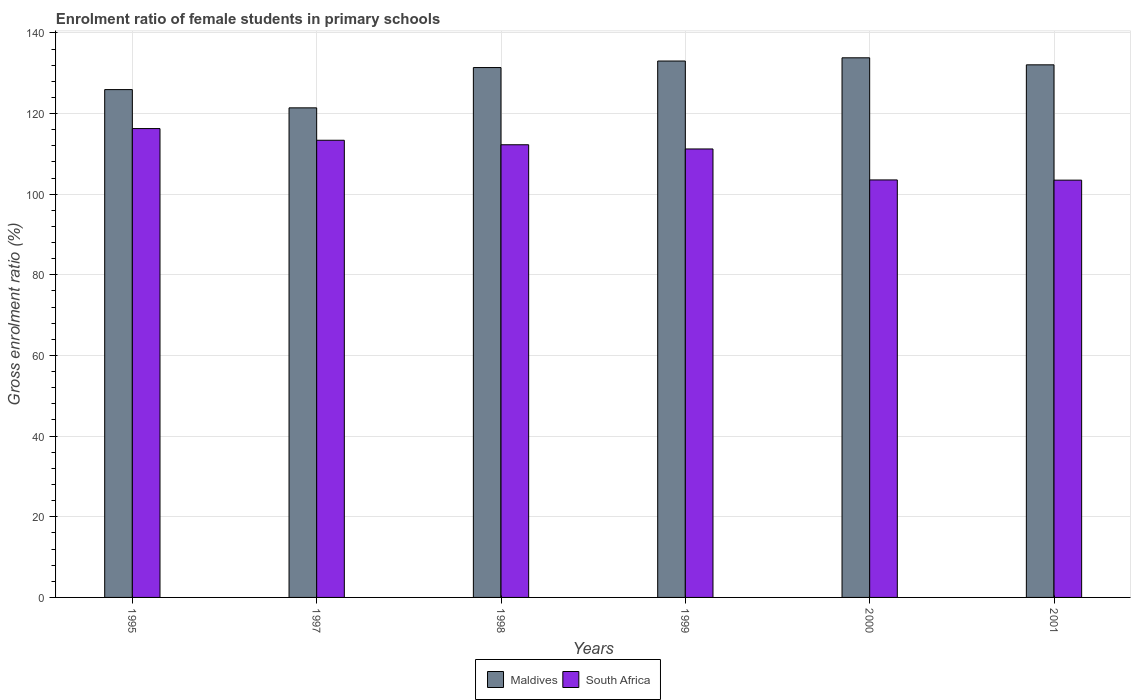Are the number of bars per tick equal to the number of legend labels?
Give a very brief answer. Yes. Are the number of bars on each tick of the X-axis equal?
Your answer should be compact. Yes. How many bars are there on the 1st tick from the left?
Your response must be concise. 2. How many bars are there on the 4th tick from the right?
Your answer should be very brief. 2. What is the label of the 5th group of bars from the left?
Offer a terse response. 2000. What is the enrolment ratio of female students in primary schools in Maldives in 1998?
Give a very brief answer. 131.4. Across all years, what is the maximum enrolment ratio of female students in primary schools in South Africa?
Give a very brief answer. 116.27. Across all years, what is the minimum enrolment ratio of female students in primary schools in Maldives?
Provide a succinct answer. 121.41. In which year was the enrolment ratio of female students in primary schools in South Africa minimum?
Provide a short and direct response. 2001. What is the total enrolment ratio of female students in primary schools in South Africa in the graph?
Make the answer very short. 660.12. What is the difference between the enrolment ratio of female students in primary schools in South Africa in 1998 and that in 1999?
Provide a succinct answer. 1.04. What is the difference between the enrolment ratio of female students in primary schools in South Africa in 1998 and the enrolment ratio of female students in primary schools in Maldives in 1995?
Make the answer very short. -13.68. What is the average enrolment ratio of female students in primary schools in Maldives per year?
Offer a terse response. 129.61. In the year 2001, what is the difference between the enrolment ratio of female students in primary schools in South Africa and enrolment ratio of female students in primary schools in Maldives?
Make the answer very short. -28.59. In how many years, is the enrolment ratio of female students in primary schools in Maldives greater than 116 %?
Offer a terse response. 6. What is the ratio of the enrolment ratio of female students in primary schools in Maldives in 1998 to that in 2001?
Keep it short and to the point. 0.99. What is the difference between the highest and the second highest enrolment ratio of female students in primary schools in Maldives?
Your answer should be very brief. 0.8. What is the difference between the highest and the lowest enrolment ratio of female students in primary schools in Maldives?
Keep it short and to the point. 12.41. What does the 2nd bar from the left in 1995 represents?
Make the answer very short. South Africa. What does the 1st bar from the right in 1995 represents?
Your response must be concise. South Africa. How many bars are there?
Provide a succinct answer. 12. What is the difference between two consecutive major ticks on the Y-axis?
Your answer should be compact. 20. Does the graph contain grids?
Offer a very short reply. Yes. How many legend labels are there?
Offer a terse response. 2. What is the title of the graph?
Provide a succinct answer. Enrolment ratio of female students in primary schools. Does "South Asia" appear as one of the legend labels in the graph?
Your response must be concise. No. What is the label or title of the X-axis?
Offer a terse response. Years. What is the Gross enrolment ratio (%) in Maldives in 1995?
Provide a short and direct response. 125.93. What is the Gross enrolment ratio (%) of South Africa in 1995?
Your answer should be compact. 116.27. What is the Gross enrolment ratio (%) of Maldives in 1997?
Your answer should be very brief. 121.41. What is the Gross enrolment ratio (%) in South Africa in 1997?
Offer a very short reply. 113.37. What is the Gross enrolment ratio (%) in Maldives in 1998?
Offer a very short reply. 131.4. What is the Gross enrolment ratio (%) in South Africa in 1998?
Offer a terse response. 112.26. What is the Gross enrolment ratio (%) in Maldives in 1999?
Give a very brief answer. 133.02. What is the Gross enrolment ratio (%) of South Africa in 1999?
Your answer should be compact. 111.21. What is the Gross enrolment ratio (%) of Maldives in 2000?
Your answer should be compact. 133.82. What is the Gross enrolment ratio (%) of South Africa in 2000?
Your response must be concise. 103.53. What is the Gross enrolment ratio (%) of Maldives in 2001?
Your answer should be compact. 132.07. What is the Gross enrolment ratio (%) of South Africa in 2001?
Make the answer very short. 103.48. Across all years, what is the maximum Gross enrolment ratio (%) in Maldives?
Make the answer very short. 133.82. Across all years, what is the maximum Gross enrolment ratio (%) of South Africa?
Keep it short and to the point. 116.27. Across all years, what is the minimum Gross enrolment ratio (%) in Maldives?
Ensure brevity in your answer.  121.41. Across all years, what is the minimum Gross enrolment ratio (%) of South Africa?
Offer a terse response. 103.48. What is the total Gross enrolment ratio (%) of Maldives in the graph?
Make the answer very short. 777.65. What is the total Gross enrolment ratio (%) in South Africa in the graph?
Make the answer very short. 660.12. What is the difference between the Gross enrolment ratio (%) in Maldives in 1995 and that in 1997?
Your answer should be very brief. 4.53. What is the difference between the Gross enrolment ratio (%) of South Africa in 1995 and that in 1997?
Offer a terse response. 2.9. What is the difference between the Gross enrolment ratio (%) in Maldives in 1995 and that in 1998?
Offer a very short reply. -5.47. What is the difference between the Gross enrolment ratio (%) of South Africa in 1995 and that in 1998?
Give a very brief answer. 4.01. What is the difference between the Gross enrolment ratio (%) in Maldives in 1995 and that in 1999?
Make the answer very short. -7.09. What is the difference between the Gross enrolment ratio (%) of South Africa in 1995 and that in 1999?
Provide a short and direct response. 5.06. What is the difference between the Gross enrolment ratio (%) in Maldives in 1995 and that in 2000?
Your answer should be very brief. -7.88. What is the difference between the Gross enrolment ratio (%) of South Africa in 1995 and that in 2000?
Your response must be concise. 12.74. What is the difference between the Gross enrolment ratio (%) in Maldives in 1995 and that in 2001?
Ensure brevity in your answer.  -6.14. What is the difference between the Gross enrolment ratio (%) of South Africa in 1995 and that in 2001?
Your answer should be very brief. 12.79. What is the difference between the Gross enrolment ratio (%) in Maldives in 1997 and that in 1998?
Offer a terse response. -9.99. What is the difference between the Gross enrolment ratio (%) in South Africa in 1997 and that in 1998?
Provide a short and direct response. 1.11. What is the difference between the Gross enrolment ratio (%) in Maldives in 1997 and that in 1999?
Offer a terse response. -11.62. What is the difference between the Gross enrolment ratio (%) in South Africa in 1997 and that in 1999?
Offer a very short reply. 2.16. What is the difference between the Gross enrolment ratio (%) of Maldives in 1997 and that in 2000?
Make the answer very short. -12.41. What is the difference between the Gross enrolment ratio (%) in South Africa in 1997 and that in 2000?
Give a very brief answer. 9.84. What is the difference between the Gross enrolment ratio (%) of Maldives in 1997 and that in 2001?
Keep it short and to the point. -10.67. What is the difference between the Gross enrolment ratio (%) of South Africa in 1997 and that in 2001?
Offer a terse response. 9.89. What is the difference between the Gross enrolment ratio (%) in Maldives in 1998 and that in 1999?
Offer a terse response. -1.62. What is the difference between the Gross enrolment ratio (%) in South Africa in 1998 and that in 1999?
Your response must be concise. 1.04. What is the difference between the Gross enrolment ratio (%) in Maldives in 1998 and that in 2000?
Your answer should be very brief. -2.42. What is the difference between the Gross enrolment ratio (%) of South Africa in 1998 and that in 2000?
Your answer should be very brief. 8.72. What is the difference between the Gross enrolment ratio (%) of Maldives in 1998 and that in 2001?
Give a very brief answer. -0.67. What is the difference between the Gross enrolment ratio (%) in South Africa in 1998 and that in 2001?
Keep it short and to the point. 8.78. What is the difference between the Gross enrolment ratio (%) of Maldives in 1999 and that in 2000?
Provide a short and direct response. -0.8. What is the difference between the Gross enrolment ratio (%) in South Africa in 1999 and that in 2000?
Keep it short and to the point. 7.68. What is the difference between the Gross enrolment ratio (%) in Maldives in 1999 and that in 2001?
Ensure brevity in your answer.  0.95. What is the difference between the Gross enrolment ratio (%) of South Africa in 1999 and that in 2001?
Your answer should be compact. 7.73. What is the difference between the Gross enrolment ratio (%) in Maldives in 2000 and that in 2001?
Provide a short and direct response. 1.74. What is the difference between the Gross enrolment ratio (%) in South Africa in 2000 and that in 2001?
Your response must be concise. 0.05. What is the difference between the Gross enrolment ratio (%) in Maldives in 1995 and the Gross enrolment ratio (%) in South Africa in 1997?
Provide a succinct answer. 12.56. What is the difference between the Gross enrolment ratio (%) of Maldives in 1995 and the Gross enrolment ratio (%) of South Africa in 1998?
Make the answer very short. 13.68. What is the difference between the Gross enrolment ratio (%) in Maldives in 1995 and the Gross enrolment ratio (%) in South Africa in 1999?
Your answer should be very brief. 14.72. What is the difference between the Gross enrolment ratio (%) of Maldives in 1995 and the Gross enrolment ratio (%) of South Africa in 2000?
Ensure brevity in your answer.  22.4. What is the difference between the Gross enrolment ratio (%) of Maldives in 1995 and the Gross enrolment ratio (%) of South Africa in 2001?
Your answer should be compact. 22.45. What is the difference between the Gross enrolment ratio (%) in Maldives in 1997 and the Gross enrolment ratio (%) in South Africa in 1998?
Give a very brief answer. 9.15. What is the difference between the Gross enrolment ratio (%) in Maldives in 1997 and the Gross enrolment ratio (%) in South Africa in 1999?
Your response must be concise. 10.19. What is the difference between the Gross enrolment ratio (%) of Maldives in 1997 and the Gross enrolment ratio (%) of South Africa in 2000?
Keep it short and to the point. 17.87. What is the difference between the Gross enrolment ratio (%) in Maldives in 1997 and the Gross enrolment ratio (%) in South Africa in 2001?
Keep it short and to the point. 17.93. What is the difference between the Gross enrolment ratio (%) of Maldives in 1998 and the Gross enrolment ratio (%) of South Africa in 1999?
Your response must be concise. 20.19. What is the difference between the Gross enrolment ratio (%) in Maldives in 1998 and the Gross enrolment ratio (%) in South Africa in 2000?
Your answer should be very brief. 27.87. What is the difference between the Gross enrolment ratio (%) of Maldives in 1998 and the Gross enrolment ratio (%) of South Africa in 2001?
Keep it short and to the point. 27.92. What is the difference between the Gross enrolment ratio (%) of Maldives in 1999 and the Gross enrolment ratio (%) of South Africa in 2000?
Make the answer very short. 29.49. What is the difference between the Gross enrolment ratio (%) in Maldives in 1999 and the Gross enrolment ratio (%) in South Africa in 2001?
Your answer should be very brief. 29.54. What is the difference between the Gross enrolment ratio (%) in Maldives in 2000 and the Gross enrolment ratio (%) in South Africa in 2001?
Keep it short and to the point. 30.34. What is the average Gross enrolment ratio (%) in Maldives per year?
Give a very brief answer. 129.61. What is the average Gross enrolment ratio (%) of South Africa per year?
Provide a succinct answer. 110.02. In the year 1995, what is the difference between the Gross enrolment ratio (%) in Maldives and Gross enrolment ratio (%) in South Africa?
Offer a very short reply. 9.66. In the year 1997, what is the difference between the Gross enrolment ratio (%) of Maldives and Gross enrolment ratio (%) of South Africa?
Keep it short and to the point. 8.04. In the year 1998, what is the difference between the Gross enrolment ratio (%) of Maldives and Gross enrolment ratio (%) of South Africa?
Give a very brief answer. 19.14. In the year 1999, what is the difference between the Gross enrolment ratio (%) in Maldives and Gross enrolment ratio (%) in South Africa?
Offer a terse response. 21.81. In the year 2000, what is the difference between the Gross enrolment ratio (%) in Maldives and Gross enrolment ratio (%) in South Africa?
Make the answer very short. 30.29. In the year 2001, what is the difference between the Gross enrolment ratio (%) in Maldives and Gross enrolment ratio (%) in South Africa?
Your response must be concise. 28.59. What is the ratio of the Gross enrolment ratio (%) in Maldives in 1995 to that in 1997?
Make the answer very short. 1.04. What is the ratio of the Gross enrolment ratio (%) in South Africa in 1995 to that in 1997?
Your response must be concise. 1.03. What is the ratio of the Gross enrolment ratio (%) in Maldives in 1995 to that in 1998?
Provide a succinct answer. 0.96. What is the ratio of the Gross enrolment ratio (%) of South Africa in 1995 to that in 1998?
Your answer should be very brief. 1.04. What is the ratio of the Gross enrolment ratio (%) of Maldives in 1995 to that in 1999?
Give a very brief answer. 0.95. What is the ratio of the Gross enrolment ratio (%) of South Africa in 1995 to that in 1999?
Offer a very short reply. 1.05. What is the ratio of the Gross enrolment ratio (%) in Maldives in 1995 to that in 2000?
Keep it short and to the point. 0.94. What is the ratio of the Gross enrolment ratio (%) in South Africa in 1995 to that in 2000?
Give a very brief answer. 1.12. What is the ratio of the Gross enrolment ratio (%) of Maldives in 1995 to that in 2001?
Keep it short and to the point. 0.95. What is the ratio of the Gross enrolment ratio (%) in South Africa in 1995 to that in 2001?
Keep it short and to the point. 1.12. What is the ratio of the Gross enrolment ratio (%) of Maldives in 1997 to that in 1998?
Provide a succinct answer. 0.92. What is the ratio of the Gross enrolment ratio (%) in South Africa in 1997 to that in 1998?
Offer a very short reply. 1.01. What is the ratio of the Gross enrolment ratio (%) in Maldives in 1997 to that in 1999?
Offer a terse response. 0.91. What is the ratio of the Gross enrolment ratio (%) of South Africa in 1997 to that in 1999?
Offer a very short reply. 1.02. What is the ratio of the Gross enrolment ratio (%) in Maldives in 1997 to that in 2000?
Make the answer very short. 0.91. What is the ratio of the Gross enrolment ratio (%) in South Africa in 1997 to that in 2000?
Provide a short and direct response. 1.09. What is the ratio of the Gross enrolment ratio (%) of Maldives in 1997 to that in 2001?
Make the answer very short. 0.92. What is the ratio of the Gross enrolment ratio (%) of South Africa in 1997 to that in 2001?
Offer a very short reply. 1.1. What is the ratio of the Gross enrolment ratio (%) of Maldives in 1998 to that in 1999?
Offer a terse response. 0.99. What is the ratio of the Gross enrolment ratio (%) of South Africa in 1998 to that in 1999?
Provide a short and direct response. 1.01. What is the ratio of the Gross enrolment ratio (%) in Maldives in 1998 to that in 2000?
Your response must be concise. 0.98. What is the ratio of the Gross enrolment ratio (%) of South Africa in 1998 to that in 2000?
Provide a short and direct response. 1.08. What is the ratio of the Gross enrolment ratio (%) of South Africa in 1998 to that in 2001?
Make the answer very short. 1.08. What is the ratio of the Gross enrolment ratio (%) in South Africa in 1999 to that in 2000?
Your answer should be compact. 1.07. What is the ratio of the Gross enrolment ratio (%) in Maldives in 1999 to that in 2001?
Your response must be concise. 1.01. What is the ratio of the Gross enrolment ratio (%) of South Africa in 1999 to that in 2001?
Your response must be concise. 1.07. What is the ratio of the Gross enrolment ratio (%) in Maldives in 2000 to that in 2001?
Offer a very short reply. 1.01. What is the ratio of the Gross enrolment ratio (%) of South Africa in 2000 to that in 2001?
Make the answer very short. 1. What is the difference between the highest and the second highest Gross enrolment ratio (%) in Maldives?
Make the answer very short. 0.8. What is the difference between the highest and the second highest Gross enrolment ratio (%) in South Africa?
Give a very brief answer. 2.9. What is the difference between the highest and the lowest Gross enrolment ratio (%) in Maldives?
Give a very brief answer. 12.41. What is the difference between the highest and the lowest Gross enrolment ratio (%) in South Africa?
Offer a very short reply. 12.79. 